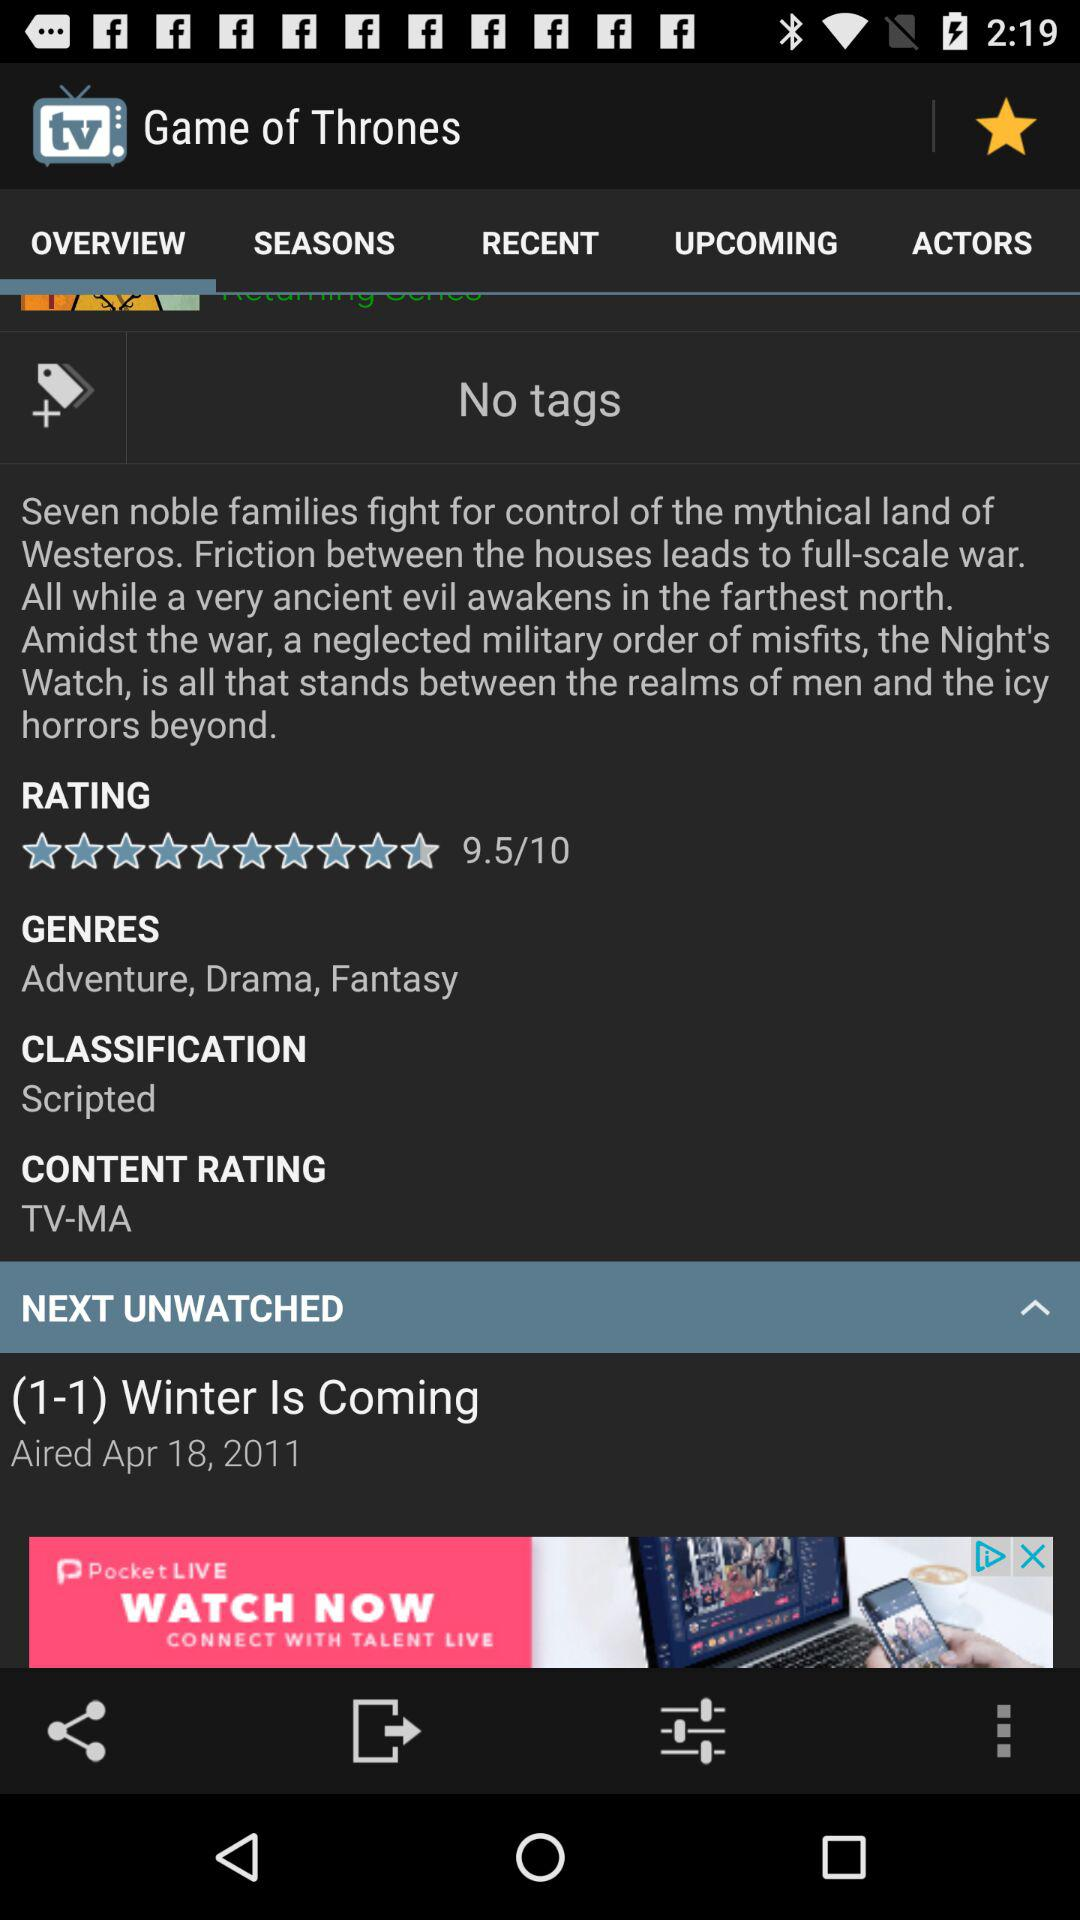What is the rating of the game? The rating of the game is 9.5. 